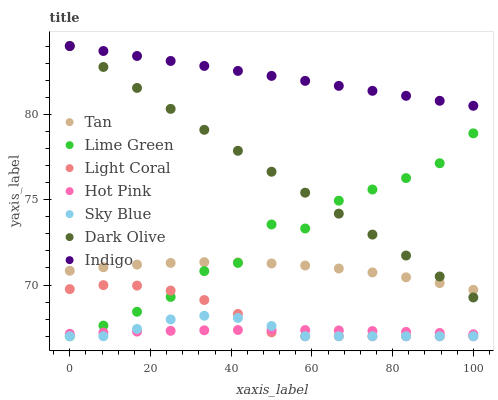Does Hot Pink have the minimum area under the curve?
Answer yes or no. Yes. Does Indigo have the maximum area under the curve?
Answer yes or no. Yes. Does Indigo have the minimum area under the curve?
Answer yes or no. No. Does Hot Pink have the maximum area under the curve?
Answer yes or no. No. Is Dark Olive the smoothest?
Answer yes or no. Yes. Is Lime Green the roughest?
Answer yes or no. Yes. Is Indigo the smoothest?
Answer yes or no. No. Is Indigo the roughest?
Answer yes or no. No. Does Light Coral have the lowest value?
Answer yes or no. Yes. Does Hot Pink have the lowest value?
Answer yes or no. No. Does Indigo have the highest value?
Answer yes or no. Yes. Does Hot Pink have the highest value?
Answer yes or no. No. Is Hot Pink less than Indigo?
Answer yes or no. Yes. Is Dark Olive greater than Sky Blue?
Answer yes or no. Yes. Does Lime Green intersect Light Coral?
Answer yes or no. Yes. Is Lime Green less than Light Coral?
Answer yes or no. No. Is Lime Green greater than Light Coral?
Answer yes or no. No. Does Hot Pink intersect Indigo?
Answer yes or no. No. 